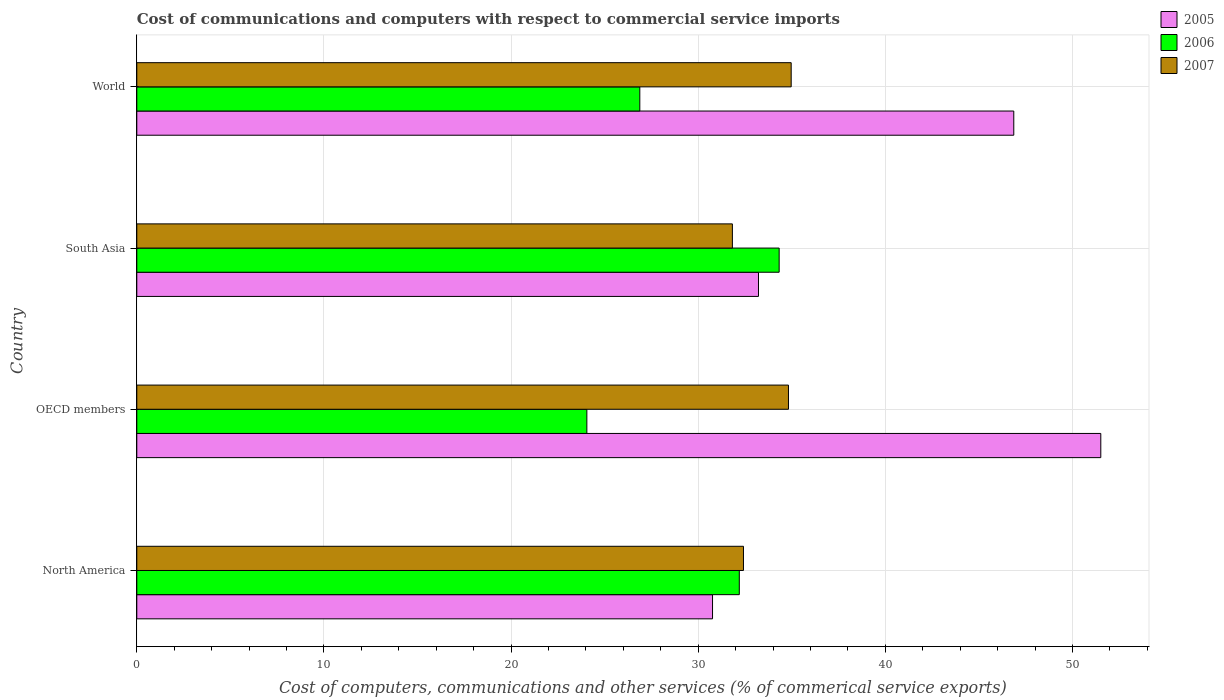How many different coloured bars are there?
Your answer should be compact. 3. How many bars are there on the 4th tick from the bottom?
Offer a terse response. 3. What is the cost of communications and computers in 2007 in South Asia?
Offer a very short reply. 31.83. Across all countries, what is the maximum cost of communications and computers in 2007?
Ensure brevity in your answer.  34.97. Across all countries, what is the minimum cost of communications and computers in 2006?
Your response must be concise. 24.05. In which country was the cost of communications and computers in 2005 maximum?
Your answer should be compact. OECD members. In which country was the cost of communications and computers in 2006 minimum?
Offer a very short reply. OECD members. What is the total cost of communications and computers in 2006 in the graph?
Ensure brevity in your answer.  117.45. What is the difference between the cost of communications and computers in 2005 in South Asia and that in World?
Your answer should be very brief. -13.64. What is the difference between the cost of communications and computers in 2005 in North America and the cost of communications and computers in 2006 in OECD members?
Provide a succinct answer. 6.72. What is the average cost of communications and computers in 2005 per country?
Provide a short and direct response. 40.59. What is the difference between the cost of communications and computers in 2007 and cost of communications and computers in 2006 in North America?
Your response must be concise. 0.22. In how many countries, is the cost of communications and computers in 2005 greater than 34 %?
Provide a short and direct response. 2. What is the ratio of the cost of communications and computers in 2006 in North America to that in South Asia?
Keep it short and to the point. 0.94. What is the difference between the highest and the second highest cost of communications and computers in 2006?
Give a very brief answer. 2.13. What is the difference between the highest and the lowest cost of communications and computers in 2006?
Provide a short and direct response. 10.28. Is it the case that in every country, the sum of the cost of communications and computers in 2005 and cost of communications and computers in 2007 is greater than the cost of communications and computers in 2006?
Provide a succinct answer. Yes. How many bars are there?
Your answer should be compact. 12. How many countries are there in the graph?
Your response must be concise. 4. Does the graph contain any zero values?
Ensure brevity in your answer.  No. Does the graph contain grids?
Your response must be concise. Yes. How many legend labels are there?
Give a very brief answer. 3. What is the title of the graph?
Your response must be concise. Cost of communications and computers with respect to commercial service imports. Does "1996" appear as one of the legend labels in the graph?
Offer a very short reply. No. What is the label or title of the X-axis?
Ensure brevity in your answer.  Cost of computers, communications and other services (% of commerical service exports). What is the label or title of the Y-axis?
Your response must be concise. Country. What is the Cost of computers, communications and other services (% of commerical service exports) of 2005 in North America?
Offer a terse response. 30.77. What is the Cost of computers, communications and other services (% of commerical service exports) in 2006 in North America?
Keep it short and to the point. 32.2. What is the Cost of computers, communications and other services (% of commerical service exports) of 2007 in North America?
Ensure brevity in your answer.  32.42. What is the Cost of computers, communications and other services (% of commerical service exports) of 2005 in OECD members?
Provide a short and direct response. 51.51. What is the Cost of computers, communications and other services (% of commerical service exports) of 2006 in OECD members?
Provide a succinct answer. 24.05. What is the Cost of computers, communications and other services (% of commerical service exports) in 2007 in OECD members?
Provide a short and direct response. 34.82. What is the Cost of computers, communications and other services (% of commerical service exports) of 2005 in South Asia?
Your response must be concise. 33.22. What is the Cost of computers, communications and other services (% of commerical service exports) of 2006 in South Asia?
Your answer should be very brief. 34.33. What is the Cost of computers, communications and other services (% of commerical service exports) in 2007 in South Asia?
Your response must be concise. 31.83. What is the Cost of computers, communications and other services (% of commerical service exports) in 2005 in World?
Provide a succinct answer. 46.86. What is the Cost of computers, communications and other services (% of commerical service exports) in 2006 in World?
Make the answer very short. 26.88. What is the Cost of computers, communications and other services (% of commerical service exports) of 2007 in World?
Your answer should be very brief. 34.97. Across all countries, what is the maximum Cost of computers, communications and other services (% of commerical service exports) in 2005?
Provide a short and direct response. 51.51. Across all countries, what is the maximum Cost of computers, communications and other services (% of commerical service exports) of 2006?
Ensure brevity in your answer.  34.33. Across all countries, what is the maximum Cost of computers, communications and other services (% of commerical service exports) of 2007?
Ensure brevity in your answer.  34.97. Across all countries, what is the minimum Cost of computers, communications and other services (% of commerical service exports) of 2005?
Your answer should be compact. 30.77. Across all countries, what is the minimum Cost of computers, communications and other services (% of commerical service exports) in 2006?
Ensure brevity in your answer.  24.05. Across all countries, what is the minimum Cost of computers, communications and other services (% of commerical service exports) of 2007?
Make the answer very short. 31.83. What is the total Cost of computers, communications and other services (% of commerical service exports) of 2005 in the graph?
Keep it short and to the point. 162.36. What is the total Cost of computers, communications and other services (% of commerical service exports) in 2006 in the graph?
Keep it short and to the point. 117.45. What is the total Cost of computers, communications and other services (% of commerical service exports) of 2007 in the graph?
Offer a terse response. 134.04. What is the difference between the Cost of computers, communications and other services (% of commerical service exports) in 2005 in North America and that in OECD members?
Offer a very short reply. -20.75. What is the difference between the Cost of computers, communications and other services (% of commerical service exports) in 2006 in North America and that in OECD members?
Your answer should be very brief. 8.15. What is the difference between the Cost of computers, communications and other services (% of commerical service exports) in 2007 in North America and that in OECD members?
Your response must be concise. -2.4. What is the difference between the Cost of computers, communications and other services (% of commerical service exports) in 2005 in North America and that in South Asia?
Provide a short and direct response. -2.46. What is the difference between the Cost of computers, communications and other services (% of commerical service exports) of 2006 in North America and that in South Asia?
Your response must be concise. -2.13. What is the difference between the Cost of computers, communications and other services (% of commerical service exports) in 2007 in North America and that in South Asia?
Provide a short and direct response. 0.59. What is the difference between the Cost of computers, communications and other services (% of commerical service exports) in 2005 in North America and that in World?
Give a very brief answer. -16.1. What is the difference between the Cost of computers, communications and other services (% of commerical service exports) of 2006 in North America and that in World?
Provide a short and direct response. 5.32. What is the difference between the Cost of computers, communications and other services (% of commerical service exports) of 2007 in North America and that in World?
Keep it short and to the point. -2.55. What is the difference between the Cost of computers, communications and other services (% of commerical service exports) of 2005 in OECD members and that in South Asia?
Provide a succinct answer. 18.29. What is the difference between the Cost of computers, communications and other services (% of commerical service exports) in 2006 in OECD members and that in South Asia?
Your response must be concise. -10.28. What is the difference between the Cost of computers, communications and other services (% of commerical service exports) of 2007 in OECD members and that in South Asia?
Your answer should be very brief. 3. What is the difference between the Cost of computers, communications and other services (% of commerical service exports) in 2005 in OECD members and that in World?
Offer a very short reply. 4.65. What is the difference between the Cost of computers, communications and other services (% of commerical service exports) of 2006 in OECD members and that in World?
Offer a terse response. -2.83. What is the difference between the Cost of computers, communications and other services (% of commerical service exports) in 2007 in OECD members and that in World?
Keep it short and to the point. -0.15. What is the difference between the Cost of computers, communications and other services (% of commerical service exports) in 2005 in South Asia and that in World?
Make the answer very short. -13.64. What is the difference between the Cost of computers, communications and other services (% of commerical service exports) of 2006 in South Asia and that in World?
Your answer should be very brief. 7.45. What is the difference between the Cost of computers, communications and other services (% of commerical service exports) in 2007 in South Asia and that in World?
Your response must be concise. -3.14. What is the difference between the Cost of computers, communications and other services (% of commerical service exports) in 2005 in North America and the Cost of computers, communications and other services (% of commerical service exports) in 2006 in OECD members?
Offer a very short reply. 6.72. What is the difference between the Cost of computers, communications and other services (% of commerical service exports) of 2005 in North America and the Cost of computers, communications and other services (% of commerical service exports) of 2007 in OECD members?
Ensure brevity in your answer.  -4.06. What is the difference between the Cost of computers, communications and other services (% of commerical service exports) of 2006 in North America and the Cost of computers, communications and other services (% of commerical service exports) of 2007 in OECD members?
Give a very brief answer. -2.63. What is the difference between the Cost of computers, communications and other services (% of commerical service exports) in 2005 in North America and the Cost of computers, communications and other services (% of commerical service exports) in 2006 in South Asia?
Your answer should be very brief. -3.56. What is the difference between the Cost of computers, communications and other services (% of commerical service exports) in 2005 in North America and the Cost of computers, communications and other services (% of commerical service exports) in 2007 in South Asia?
Offer a terse response. -1.06. What is the difference between the Cost of computers, communications and other services (% of commerical service exports) of 2006 in North America and the Cost of computers, communications and other services (% of commerical service exports) of 2007 in South Asia?
Offer a very short reply. 0.37. What is the difference between the Cost of computers, communications and other services (% of commerical service exports) of 2005 in North America and the Cost of computers, communications and other services (% of commerical service exports) of 2006 in World?
Ensure brevity in your answer.  3.89. What is the difference between the Cost of computers, communications and other services (% of commerical service exports) of 2005 in North America and the Cost of computers, communications and other services (% of commerical service exports) of 2007 in World?
Give a very brief answer. -4.2. What is the difference between the Cost of computers, communications and other services (% of commerical service exports) of 2006 in North America and the Cost of computers, communications and other services (% of commerical service exports) of 2007 in World?
Ensure brevity in your answer.  -2.77. What is the difference between the Cost of computers, communications and other services (% of commerical service exports) of 2005 in OECD members and the Cost of computers, communications and other services (% of commerical service exports) of 2006 in South Asia?
Provide a succinct answer. 17.19. What is the difference between the Cost of computers, communications and other services (% of commerical service exports) in 2005 in OECD members and the Cost of computers, communications and other services (% of commerical service exports) in 2007 in South Asia?
Offer a terse response. 19.69. What is the difference between the Cost of computers, communications and other services (% of commerical service exports) of 2006 in OECD members and the Cost of computers, communications and other services (% of commerical service exports) of 2007 in South Asia?
Provide a succinct answer. -7.78. What is the difference between the Cost of computers, communications and other services (% of commerical service exports) of 2005 in OECD members and the Cost of computers, communications and other services (% of commerical service exports) of 2006 in World?
Provide a short and direct response. 24.63. What is the difference between the Cost of computers, communications and other services (% of commerical service exports) of 2005 in OECD members and the Cost of computers, communications and other services (% of commerical service exports) of 2007 in World?
Offer a very short reply. 16.54. What is the difference between the Cost of computers, communications and other services (% of commerical service exports) of 2006 in OECD members and the Cost of computers, communications and other services (% of commerical service exports) of 2007 in World?
Your response must be concise. -10.92. What is the difference between the Cost of computers, communications and other services (% of commerical service exports) in 2005 in South Asia and the Cost of computers, communications and other services (% of commerical service exports) in 2006 in World?
Your answer should be compact. 6.34. What is the difference between the Cost of computers, communications and other services (% of commerical service exports) of 2005 in South Asia and the Cost of computers, communications and other services (% of commerical service exports) of 2007 in World?
Keep it short and to the point. -1.75. What is the difference between the Cost of computers, communications and other services (% of commerical service exports) in 2006 in South Asia and the Cost of computers, communications and other services (% of commerical service exports) in 2007 in World?
Keep it short and to the point. -0.64. What is the average Cost of computers, communications and other services (% of commerical service exports) in 2005 per country?
Give a very brief answer. 40.59. What is the average Cost of computers, communications and other services (% of commerical service exports) in 2006 per country?
Offer a very short reply. 29.36. What is the average Cost of computers, communications and other services (% of commerical service exports) of 2007 per country?
Ensure brevity in your answer.  33.51. What is the difference between the Cost of computers, communications and other services (% of commerical service exports) of 2005 and Cost of computers, communications and other services (% of commerical service exports) of 2006 in North America?
Your response must be concise. -1.43. What is the difference between the Cost of computers, communications and other services (% of commerical service exports) in 2005 and Cost of computers, communications and other services (% of commerical service exports) in 2007 in North America?
Offer a very short reply. -1.65. What is the difference between the Cost of computers, communications and other services (% of commerical service exports) in 2006 and Cost of computers, communications and other services (% of commerical service exports) in 2007 in North America?
Give a very brief answer. -0.22. What is the difference between the Cost of computers, communications and other services (% of commerical service exports) in 2005 and Cost of computers, communications and other services (% of commerical service exports) in 2006 in OECD members?
Offer a terse response. 27.46. What is the difference between the Cost of computers, communications and other services (% of commerical service exports) of 2005 and Cost of computers, communications and other services (% of commerical service exports) of 2007 in OECD members?
Provide a short and direct response. 16.69. What is the difference between the Cost of computers, communications and other services (% of commerical service exports) of 2006 and Cost of computers, communications and other services (% of commerical service exports) of 2007 in OECD members?
Your response must be concise. -10.77. What is the difference between the Cost of computers, communications and other services (% of commerical service exports) in 2005 and Cost of computers, communications and other services (% of commerical service exports) in 2006 in South Asia?
Make the answer very short. -1.1. What is the difference between the Cost of computers, communications and other services (% of commerical service exports) of 2005 and Cost of computers, communications and other services (% of commerical service exports) of 2007 in South Asia?
Make the answer very short. 1.39. What is the difference between the Cost of computers, communications and other services (% of commerical service exports) of 2006 and Cost of computers, communications and other services (% of commerical service exports) of 2007 in South Asia?
Your response must be concise. 2.5. What is the difference between the Cost of computers, communications and other services (% of commerical service exports) of 2005 and Cost of computers, communications and other services (% of commerical service exports) of 2006 in World?
Keep it short and to the point. 19.98. What is the difference between the Cost of computers, communications and other services (% of commerical service exports) of 2005 and Cost of computers, communications and other services (% of commerical service exports) of 2007 in World?
Make the answer very short. 11.89. What is the difference between the Cost of computers, communications and other services (% of commerical service exports) of 2006 and Cost of computers, communications and other services (% of commerical service exports) of 2007 in World?
Give a very brief answer. -8.09. What is the ratio of the Cost of computers, communications and other services (% of commerical service exports) in 2005 in North America to that in OECD members?
Your answer should be compact. 0.6. What is the ratio of the Cost of computers, communications and other services (% of commerical service exports) in 2006 in North America to that in OECD members?
Offer a very short reply. 1.34. What is the ratio of the Cost of computers, communications and other services (% of commerical service exports) in 2005 in North America to that in South Asia?
Offer a very short reply. 0.93. What is the ratio of the Cost of computers, communications and other services (% of commerical service exports) of 2006 in North America to that in South Asia?
Provide a short and direct response. 0.94. What is the ratio of the Cost of computers, communications and other services (% of commerical service exports) in 2007 in North America to that in South Asia?
Your answer should be compact. 1.02. What is the ratio of the Cost of computers, communications and other services (% of commerical service exports) in 2005 in North America to that in World?
Keep it short and to the point. 0.66. What is the ratio of the Cost of computers, communications and other services (% of commerical service exports) in 2006 in North America to that in World?
Ensure brevity in your answer.  1.2. What is the ratio of the Cost of computers, communications and other services (% of commerical service exports) of 2007 in North America to that in World?
Offer a terse response. 0.93. What is the ratio of the Cost of computers, communications and other services (% of commerical service exports) in 2005 in OECD members to that in South Asia?
Keep it short and to the point. 1.55. What is the ratio of the Cost of computers, communications and other services (% of commerical service exports) of 2006 in OECD members to that in South Asia?
Keep it short and to the point. 0.7. What is the ratio of the Cost of computers, communications and other services (% of commerical service exports) in 2007 in OECD members to that in South Asia?
Make the answer very short. 1.09. What is the ratio of the Cost of computers, communications and other services (% of commerical service exports) in 2005 in OECD members to that in World?
Your answer should be very brief. 1.1. What is the ratio of the Cost of computers, communications and other services (% of commerical service exports) in 2006 in OECD members to that in World?
Your answer should be compact. 0.89. What is the ratio of the Cost of computers, communications and other services (% of commerical service exports) of 2007 in OECD members to that in World?
Provide a succinct answer. 1. What is the ratio of the Cost of computers, communications and other services (% of commerical service exports) in 2005 in South Asia to that in World?
Make the answer very short. 0.71. What is the ratio of the Cost of computers, communications and other services (% of commerical service exports) of 2006 in South Asia to that in World?
Offer a terse response. 1.28. What is the ratio of the Cost of computers, communications and other services (% of commerical service exports) of 2007 in South Asia to that in World?
Make the answer very short. 0.91. What is the difference between the highest and the second highest Cost of computers, communications and other services (% of commerical service exports) in 2005?
Offer a terse response. 4.65. What is the difference between the highest and the second highest Cost of computers, communications and other services (% of commerical service exports) in 2006?
Provide a short and direct response. 2.13. What is the difference between the highest and the second highest Cost of computers, communications and other services (% of commerical service exports) of 2007?
Make the answer very short. 0.15. What is the difference between the highest and the lowest Cost of computers, communications and other services (% of commerical service exports) in 2005?
Provide a succinct answer. 20.75. What is the difference between the highest and the lowest Cost of computers, communications and other services (% of commerical service exports) in 2006?
Your response must be concise. 10.28. What is the difference between the highest and the lowest Cost of computers, communications and other services (% of commerical service exports) in 2007?
Your answer should be very brief. 3.14. 